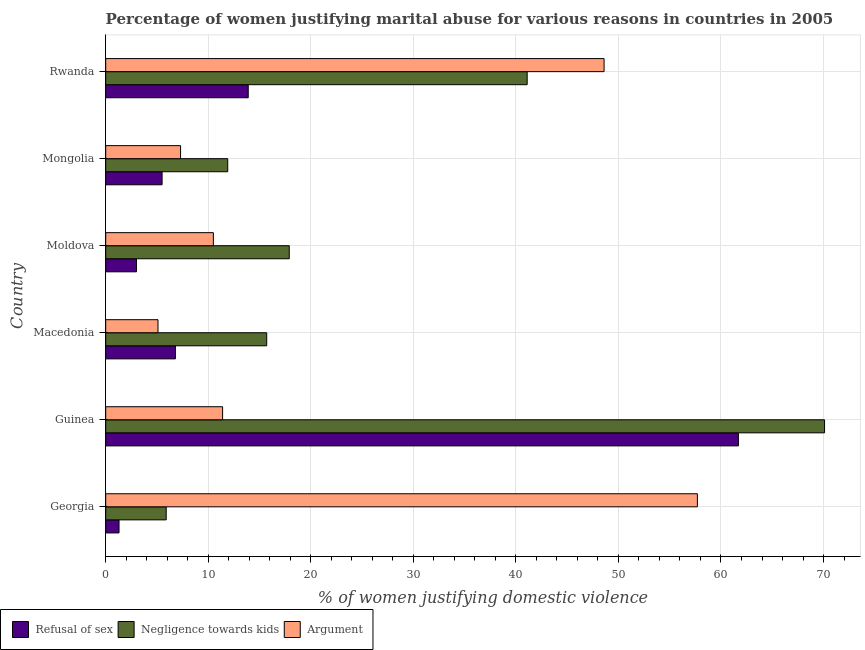How many different coloured bars are there?
Your response must be concise. 3. What is the label of the 6th group of bars from the top?
Keep it short and to the point. Georgia. What is the percentage of women justifying domestic violence due to arguments in Rwanda?
Ensure brevity in your answer.  48.6. Across all countries, what is the maximum percentage of women justifying domestic violence due to arguments?
Make the answer very short. 57.7. Across all countries, what is the minimum percentage of women justifying domestic violence due to arguments?
Give a very brief answer. 5.1. In which country was the percentage of women justifying domestic violence due to arguments maximum?
Make the answer very short. Georgia. In which country was the percentage of women justifying domestic violence due to refusal of sex minimum?
Ensure brevity in your answer.  Georgia. What is the total percentage of women justifying domestic violence due to negligence towards kids in the graph?
Your answer should be very brief. 162.6. What is the difference between the percentage of women justifying domestic violence due to refusal of sex in Guinea and that in Mongolia?
Offer a very short reply. 56.2. What is the difference between the percentage of women justifying domestic violence due to arguments in Guinea and the percentage of women justifying domestic violence due to refusal of sex in Macedonia?
Your answer should be very brief. 4.6. What is the average percentage of women justifying domestic violence due to negligence towards kids per country?
Make the answer very short. 27.1. What is the ratio of the percentage of women justifying domestic violence due to arguments in Georgia to that in Mongolia?
Your response must be concise. 7.9. What is the difference between the highest and the lowest percentage of women justifying domestic violence due to arguments?
Ensure brevity in your answer.  52.6. In how many countries, is the percentage of women justifying domestic violence due to negligence towards kids greater than the average percentage of women justifying domestic violence due to negligence towards kids taken over all countries?
Your answer should be very brief. 2. What does the 3rd bar from the top in Rwanda represents?
Keep it short and to the point. Refusal of sex. What does the 3rd bar from the bottom in Macedonia represents?
Keep it short and to the point. Argument. Is it the case that in every country, the sum of the percentage of women justifying domestic violence due to refusal of sex and percentage of women justifying domestic violence due to negligence towards kids is greater than the percentage of women justifying domestic violence due to arguments?
Offer a terse response. No. How many bars are there?
Make the answer very short. 18. Does the graph contain grids?
Offer a terse response. Yes. Where does the legend appear in the graph?
Keep it short and to the point. Bottom left. How many legend labels are there?
Offer a terse response. 3. How are the legend labels stacked?
Provide a succinct answer. Horizontal. What is the title of the graph?
Provide a succinct answer. Percentage of women justifying marital abuse for various reasons in countries in 2005. Does "Taxes on income" appear as one of the legend labels in the graph?
Give a very brief answer. No. What is the label or title of the X-axis?
Your answer should be compact. % of women justifying domestic violence. What is the label or title of the Y-axis?
Your answer should be very brief. Country. What is the % of women justifying domestic violence of Refusal of sex in Georgia?
Ensure brevity in your answer.  1.3. What is the % of women justifying domestic violence of Argument in Georgia?
Your answer should be very brief. 57.7. What is the % of women justifying domestic violence in Refusal of sex in Guinea?
Make the answer very short. 61.7. What is the % of women justifying domestic violence of Negligence towards kids in Guinea?
Offer a very short reply. 70.1. What is the % of women justifying domestic violence of Refusal of sex in Macedonia?
Provide a short and direct response. 6.8. What is the % of women justifying domestic violence in Argument in Macedonia?
Make the answer very short. 5.1. What is the % of women justifying domestic violence in Negligence towards kids in Moldova?
Give a very brief answer. 17.9. What is the % of women justifying domestic violence of Argument in Moldova?
Ensure brevity in your answer.  10.5. What is the % of women justifying domestic violence of Argument in Mongolia?
Your answer should be very brief. 7.3. What is the % of women justifying domestic violence of Refusal of sex in Rwanda?
Ensure brevity in your answer.  13.9. What is the % of women justifying domestic violence in Negligence towards kids in Rwanda?
Ensure brevity in your answer.  41.1. What is the % of women justifying domestic violence of Argument in Rwanda?
Your answer should be compact. 48.6. Across all countries, what is the maximum % of women justifying domestic violence of Refusal of sex?
Your answer should be very brief. 61.7. Across all countries, what is the maximum % of women justifying domestic violence of Negligence towards kids?
Your answer should be very brief. 70.1. Across all countries, what is the maximum % of women justifying domestic violence of Argument?
Provide a succinct answer. 57.7. Across all countries, what is the minimum % of women justifying domestic violence in Refusal of sex?
Offer a very short reply. 1.3. Across all countries, what is the minimum % of women justifying domestic violence of Argument?
Make the answer very short. 5.1. What is the total % of women justifying domestic violence of Refusal of sex in the graph?
Your response must be concise. 92.2. What is the total % of women justifying domestic violence in Negligence towards kids in the graph?
Provide a short and direct response. 162.6. What is the total % of women justifying domestic violence in Argument in the graph?
Give a very brief answer. 140.6. What is the difference between the % of women justifying domestic violence in Refusal of sex in Georgia and that in Guinea?
Offer a very short reply. -60.4. What is the difference between the % of women justifying domestic violence in Negligence towards kids in Georgia and that in Guinea?
Offer a terse response. -64.2. What is the difference between the % of women justifying domestic violence in Argument in Georgia and that in Guinea?
Make the answer very short. 46.3. What is the difference between the % of women justifying domestic violence of Refusal of sex in Georgia and that in Macedonia?
Your response must be concise. -5.5. What is the difference between the % of women justifying domestic violence in Argument in Georgia and that in Macedonia?
Ensure brevity in your answer.  52.6. What is the difference between the % of women justifying domestic violence in Refusal of sex in Georgia and that in Moldova?
Provide a succinct answer. -1.7. What is the difference between the % of women justifying domestic violence of Argument in Georgia and that in Moldova?
Ensure brevity in your answer.  47.2. What is the difference between the % of women justifying domestic violence in Negligence towards kids in Georgia and that in Mongolia?
Provide a succinct answer. -6. What is the difference between the % of women justifying domestic violence in Argument in Georgia and that in Mongolia?
Your response must be concise. 50.4. What is the difference between the % of women justifying domestic violence in Refusal of sex in Georgia and that in Rwanda?
Provide a succinct answer. -12.6. What is the difference between the % of women justifying domestic violence in Negligence towards kids in Georgia and that in Rwanda?
Make the answer very short. -35.2. What is the difference between the % of women justifying domestic violence in Refusal of sex in Guinea and that in Macedonia?
Make the answer very short. 54.9. What is the difference between the % of women justifying domestic violence in Negligence towards kids in Guinea and that in Macedonia?
Keep it short and to the point. 54.4. What is the difference between the % of women justifying domestic violence in Argument in Guinea and that in Macedonia?
Provide a succinct answer. 6.3. What is the difference between the % of women justifying domestic violence of Refusal of sex in Guinea and that in Moldova?
Provide a succinct answer. 58.7. What is the difference between the % of women justifying domestic violence of Negligence towards kids in Guinea and that in Moldova?
Your answer should be compact. 52.2. What is the difference between the % of women justifying domestic violence in Argument in Guinea and that in Moldova?
Give a very brief answer. 0.9. What is the difference between the % of women justifying domestic violence in Refusal of sex in Guinea and that in Mongolia?
Give a very brief answer. 56.2. What is the difference between the % of women justifying domestic violence in Negligence towards kids in Guinea and that in Mongolia?
Offer a very short reply. 58.2. What is the difference between the % of women justifying domestic violence in Argument in Guinea and that in Mongolia?
Provide a short and direct response. 4.1. What is the difference between the % of women justifying domestic violence in Refusal of sex in Guinea and that in Rwanda?
Your answer should be very brief. 47.8. What is the difference between the % of women justifying domestic violence of Argument in Guinea and that in Rwanda?
Give a very brief answer. -37.2. What is the difference between the % of women justifying domestic violence in Negligence towards kids in Macedonia and that in Moldova?
Make the answer very short. -2.2. What is the difference between the % of women justifying domestic violence of Argument in Macedonia and that in Mongolia?
Your answer should be compact. -2.2. What is the difference between the % of women justifying domestic violence of Refusal of sex in Macedonia and that in Rwanda?
Provide a short and direct response. -7.1. What is the difference between the % of women justifying domestic violence of Negligence towards kids in Macedonia and that in Rwanda?
Keep it short and to the point. -25.4. What is the difference between the % of women justifying domestic violence in Argument in Macedonia and that in Rwanda?
Your response must be concise. -43.5. What is the difference between the % of women justifying domestic violence of Refusal of sex in Moldova and that in Rwanda?
Your answer should be compact. -10.9. What is the difference between the % of women justifying domestic violence of Negligence towards kids in Moldova and that in Rwanda?
Ensure brevity in your answer.  -23.2. What is the difference between the % of women justifying domestic violence in Argument in Moldova and that in Rwanda?
Offer a very short reply. -38.1. What is the difference between the % of women justifying domestic violence of Negligence towards kids in Mongolia and that in Rwanda?
Ensure brevity in your answer.  -29.2. What is the difference between the % of women justifying domestic violence in Argument in Mongolia and that in Rwanda?
Provide a short and direct response. -41.3. What is the difference between the % of women justifying domestic violence in Refusal of sex in Georgia and the % of women justifying domestic violence in Negligence towards kids in Guinea?
Offer a very short reply. -68.8. What is the difference between the % of women justifying domestic violence in Refusal of sex in Georgia and the % of women justifying domestic violence in Negligence towards kids in Macedonia?
Provide a short and direct response. -14.4. What is the difference between the % of women justifying domestic violence in Refusal of sex in Georgia and the % of women justifying domestic violence in Argument in Macedonia?
Offer a terse response. -3.8. What is the difference between the % of women justifying domestic violence in Refusal of sex in Georgia and the % of women justifying domestic violence in Negligence towards kids in Moldova?
Provide a succinct answer. -16.6. What is the difference between the % of women justifying domestic violence of Refusal of sex in Georgia and the % of women justifying domestic violence of Argument in Moldova?
Ensure brevity in your answer.  -9.2. What is the difference between the % of women justifying domestic violence of Refusal of sex in Georgia and the % of women justifying domestic violence of Argument in Mongolia?
Provide a short and direct response. -6. What is the difference between the % of women justifying domestic violence in Refusal of sex in Georgia and the % of women justifying domestic violence in Negligence towards kids in Rwanda?
Your answer should be very brief. -39.8. What is the difference between the % of women justifying domestic violence of Refusal of sex in Georgia and the % of women justifying domestic violence of Argument in Rwanda?
Your answer should be compact. -47.3. What is the difference between the % of women justifying domestic violence of Negligence towards kids in Georgia and the % of women justifying domestic violence of Argument in Rwanda?
Provide a succinct answer. -42.7. What is the difference between the % of women justifying domestic violence in Refusal of sex in Guinea and the % of women justifying domestic violence in Argument in Macedonia?
Offer a terse response. 56.6. What is the difference between the % of women justifying domestic violence in Negligence towards kids in Guinea and the % of women justifying domestic violence in Argument in Macedonia?
Ensure brevity in your answer.  65. What is the difference between the % of women justifying domestic violence of Refusal of sex in Guinea and the % of women justifying domestic violence of Negligence towards kids in Moldova?
Your answer should be very brief. 43.8. What is the difference between the % of women justifying domestic violence in Refusal of sex in Guinea and the % of women justifying domestic violence in Argument in Moldova?
Ensure brevity in your answer.  51.2. What is the difference between the % of women justifying domestic violence in Negligence towards kids in Guinea and the % of women justifying domestic violence in Argument in Moldova?
Ensure brevity in your answer.  59.6. What is the difference between the % of women justifying domestic violence in Refusal of sex in Guinea and the % of women justifying domestic violence in Negligence towards kids in Mongolia?
Your response must be concise. 49.8. What is the difference between the % of women justifying domestic violence of Refusal of sex in Guinea and the % of women justifying domestic violence of Argument in Mongolia?
Your answer should be very brief. 54.4. What is the difference between the % of women justifying domestic violence of Negligence towards kids in Guinea and the % of women justifying domestic violence of Argument in Mongolia?
Provide a succinct answer. 62.8. What is the difference between the % of women justifying domestic violence in Refusal of sex in Guinea and the % of women justifying domestic violence in Negligence towards kids in Rwanda?
Your answer should be compact. 20.6. What is the difference between the % of women justifying domestic violence of Negligence towards kids in Guinea and the % of women justifying domestic violence of Argument in Rwanda?
Your response must be concise. 21.5. What is the difference between the % of women justifying domestic violence in Refusal of sex in Macedonia and the % of women justifying domestic violence in Argument in Moldova?
Provide a succinct answer. -3.7. What is the difference between the % of women justifying domestic violence in Refusal of sex in Macedonia and the % of women justifying domestic violence in Negligence towards kids in Rwanda?
Make the answer very short. -34.3. What is the difference between the % of women justifying domestic violence in Refusal of sex in Macedonia and the % of women justifying domestic violence in Argument in Rwanda?
Provide a short and direct response. -41.8. What is the difference between the % of women justifying domestic violence of Negligence towards kids in Macedonia and the % of women justifying domestic violence of Argument in Rwanda?
Your response must be concise. -32.9. What is the difference between the % of women justifying domestic violence of Refusal of sex in Moldova and the % of women justifying domestic violence of Negligence towards kids in Rwanda?
Provide a succinct answer. -38.1. What is the difference between the % of women justifying domestic violence in Refusal of sex in Moldova and the % of women justifying domestic violence in Argument in Rwanda?
Give a very brief answer. -45.6. What is the difference between the % of women justifying domestic violence in Negligence towards kids in Moldova and the % of women justifying domestic violence in Argument in Rwanda?
Your answer should be very brief. -30.7. What is the difference between the % of women justifying domestic violence in Refusal of sex in Mongolia and the % of women justifying domestic violence in Negligence towards kids in Rwanda?
Provide a succinct answer. -35.6. What is the difference between the % of women justifying domestic violence of Refusal of sex in Mongolia and the % of women justifying domestic violence of Argument in Rwanda?
Your response must be concise. -43.1. What is the difference between the % of women justifying domestic violence in Negligence towards kids in Mongolia and the % of women justifying domestic violence in Argument in Rwanda?
Offer a very short reply. -36.7. What is the average % of women justifying domestic violence in Refusal of sex per country?
Ensure brevity in your answer.  15.37. What is the average % of women justifying domestic violence in Negligence towards kids per country?
Your answer should be compact. 27.1. What is the average % of women justifying domestic violence in Argument per country?
Offer a very short reply. 23.43. What is the difference between the % of women justifying domestic violence of Refusal of sex and % of women justifying domestic violence of Argument in Georgia?
Your response must be concise. -56.4. What is the difference between the % of women justifying domestic violence in Negligence towards kids and % of women justifying domestic violence in Argument in Georgia?
Ensure brevity in your answer.  -51.8. What is the difference between the % of women justifying domestic violence in Refusal of sex and % of women justifying domestic violence in Negligence towards kids in Guinea?
Provide a succinct answer. -8.4. What is the difference between the % of women justifying domestic violence of Refusal of sex and % of women justifying domestic violence of Argument in Guinea?
Provide a short and direct response. 50.3. What is the difference between the % of women justifying domestic violence in Negligence towards kids and % of women justifying domestic violence in Argument in Guinea?
Give a very brief answer. 58.7. What is the difference between the % of women justifying domestic violence in Refusal of sex and % of women justifying domestic violence in Negligence towards kids in Macedonia?
Your response must be concise. -8.9. What is the difference between the % of women justifying domestic violence in Refusal of sex and % of women justifying domestic violence in Argument in Macedonia?
Provide a succinct answer. 1.7. What is the difference between the % of women justifying domestic violence of Negligence towards kids and % of women justifying domestic violence of Argument in Macedonia?
Your response must be concise. 10.6. What is the difference between the % of women justifying domestic violence in Refusal of sex and % of women justifying domestic violence in Negligence towards kids in Moldova?
Offer a terse response. -14.9. What is the difference between the % of women justifying domestic violence of Negligence towards kids and % of women justifying domestic violence of Argument in Mongolia?
Your answer should be compact. 4.6. What is the difference between the % of women justifying domestic violence in Refusal of sex and % of women justifying domestic violence in Negligence towards kids in Rwanda?
Your answer should be very brief. -27.2. What is the difference between the % of women justifying domestic violence of Refusal of sex and % of women justifying domestic violence of Argument in Rwanda?
Your answer should be compact. -34.7. What is the difference between the % of women justifying domestic violence in Negligence towards kids and % of women justifying domestic violence in Argument in Rwanda?
Your answer should be very brief. -7.5. What is the ratio of the % of women justifying domestic violence of Refusal of sex in Georgia to that in Guinea?
Offer a terse response. 0.02. What is the ratio of the % of women justifying domestic violence in Negligence towards kids in Georgia to that in Guinea?
Your answer should be compact. 0.08. What is the ratio of the % of women justifying domestic violence in Argument in Georgia to that in Guinea?
Make the answer very short. 5.06. What is the ratio of the % of women justifying domestic violence of Refusal of sex in Georgia to that in Macedonia?
Offer a terse response. 0.19. What is the ratio of the % of women justifying domestic violence in Negligence towards kids in Georgia to that in Macedonia?
Your response must be concise. 0.38. What is the ratio of the % of women justifying domestic violence in Argument in Georgia to that in Macedonia?
Make the answer very short. 11.31. What is the ratio of the % of women justifying domestic violence in Refusal of sex in Georgia to that in Moldova?
Offer a very short reply. 0.43. What is the ratio of the % of women justifying domestic violence of Negligence towards kids in Georgia to that in Moldova?
Offer a terse response. 0.33. What is the ratio of the % of women justifying domestic violence in Argument in Georgia to that in Moldova?
Your answer should be compact. 5.5. What is the ratio of the % of women justifying domestic violence of Refusal of sex in Georgia to that in Mongolia?
Provide a short and direct response. 0.24. What is the ratio of the % of women justifying domestic violence of Negligence towards kids in Georgia to that in Mongolia?
Your response must be concise. 0.5. What is the ratio of the % of women justifying domestic violence in Argument in Georgia to that in Mongolia?
Offer a terse response. 7.9. What is the ratio of the % of women justifying domestic violence in Refusal of sex in Georgia to that in Rwanda?
Ensure brevity in your answer.  0.09. What is the ratio of the % of women justifying domestic violence of Negligence towards kids in Georgia to that in Rwanda?
Make the answer very short. 0.14. What is the ratio of the % of women justifying domestic violence in Argument in Georgia to that in Rwanda?
Provide a succinct answer. 1.19. What is the ratio of the % of women justifying domestic violence in Refusal of sex in Guinea to that in Macedonia?
Offer a very short reply. 9.07. What is the ratio of the % of women justifying domestic violence in Negligence towards kids in Guinea to that in Macedonia?
Your answer should be compact. 4.46. What is the ratio of the % of women justifying domestic violence of Argument in Guinea to that in Macedonia?
Make the answer very short. 2.24. What is the ratio of the % of women justifying domestic violence in Refusal of sex in Guinea to that in Moldova?
Keep it short and to the point. 20.57. What is the ratio of the % of women justifying domestic violence of Negligence towards kids in Guinea to that in Moldova?
Offer a very short reply. 3.92. What is the ratio of the % of women justifying domestic violence of Argument in Guinea to that in Moldova?
Your answer should be very brief. 1.09. What is the ratio of the % of women justifying domestic violence in Refusal of sex in Guinea to that in Mongolia?
Offer a terse response. 11.22. What is the ratio of the % of women justifying domestic violence of Negligence towards kids in Guinea to that in Mongolia?
Ensure brevity in your answer.  5.89. What is the ratio of the % of women justifying domestic violence of Argument in Guinea to that in Mongolia?
Provide a short and direct response. 1.56. What is the ratio of the % of women justifying domestic violence in Refusal of sex in Guinea to that in Rwanda?
Your answer should be compact. 4.44. What is the ratio of the % of women justifying domestic violence in Negligence towards kids in Guinea to that in Rwanda?
Offer a terse response. 1.71. What is the ratio of the % of women justifying domestic violence in Argument in Guinea to that in Rwanda?
Offer a terse response. 0.23. What is the ratio of the % of women justifying domestic violence of Refusal of sex in Macedonia to that in Moldova?
Your answer should be compact. 2.27. What is the ratio of the % of women justifying domestic violence in Negligence towards kids in Macedonia to that in Moldova?
Offer a terse response. 0.88. What is the ratio of the % of women justifying domestic violence of Argument in Macedonia to that in Moldova?
Offer a terse response. 0.49. What is the ratio of the % of women justifying domestic violence in Refusal of sex in Macedonia to that in Mongolia?
Your response must be concise. 1.24. What is the ratio of the % of women justifying domestic violence of Negligence towards kids in Macedonia to that in Mongolia?
Make the answer very short. 1.32. What is the ratio of the % of women justifying domestic violence in Argument in Macedonia to that in Mongolia?
Make the answer very short. 0.7. What is the ratio of the % of women justifying domestic violence of Refusal of sex in Macedonia to that in Rwanda?
Provide a short and direct response. 0.49. What is the ratio of the % of women justifying domestic violence of Negligence towards kids in Macedonia to that in Rwanda?
Your answer should be compact. 0.38. What is the ratio of the % of women justifying domestic violence of Argument in Macedonia to that in Rwanda?
Provide a succinct answer. 0.1. What is the ratio of the % of women justifying domestic violence of Refusal of sex in Moldova to that in Mongolia?
Keep it short and to the point. 0.55. What is the ratio of the % of women justifying domestic violence of Negligence towards kids in Moldova to that in Mongolia?
Your response must be concise. 1.5. What is the ratio of the % of women justifying domestic violence in Argument in Moldova to that in Mongolia?
Ensure brevity in your answer.  1.44. What is the ratio of the % of women justifying domestic violence in Refusal of sex in Moldova to that in Rwanda?
Offer a terse response. 0.22. What is the ratio of the % of women justifying domestic violence in Negligence towards kids in Moldova to that in Rwanda?
Give a very brief answer. 0.44. What is the ratio of the % of women justifying domestic violence of Argument in Moldova to that in Rwanda?
Provide a short and direct response. 0.22. What is the ratio of the % of women justifying domestic violence of Refusal of sex in Mongolia to that in Rwanda?
Your answer should be very brief. 0.4. What is the ratio of the % of women justifying domestic violence of Negligence towards kids in Mongolia to that in Rwanda?
Your response must be concise. 0.29. What is the ratio of the % of women justifying domestic violence of Argument in Mongolia to that in Rwanda?
Give a very brief answer. 0.15. What is the difference between the highest and the second highest % of women justifying domestic violence of Refusal of sex?
Your answer should be very brief. 47.8. What is the difference between the highest and the second highest % of women justifying domestic violence of Argument?
Give a very brief answer. 9.1. What is the difference between the highest and the lowest % of women justifying domestic violence of Refusal of sex?
Your answer should be very brief. 60.4. What is the difference between the highest and the lowest % of women justifying domestic violence of Negligence towards kids?
Make the answer very short. 64.2. What is the difference between the highest and the lowest % of women justifying domestic violence of Argument?
Offer a terse response. 52.6. 